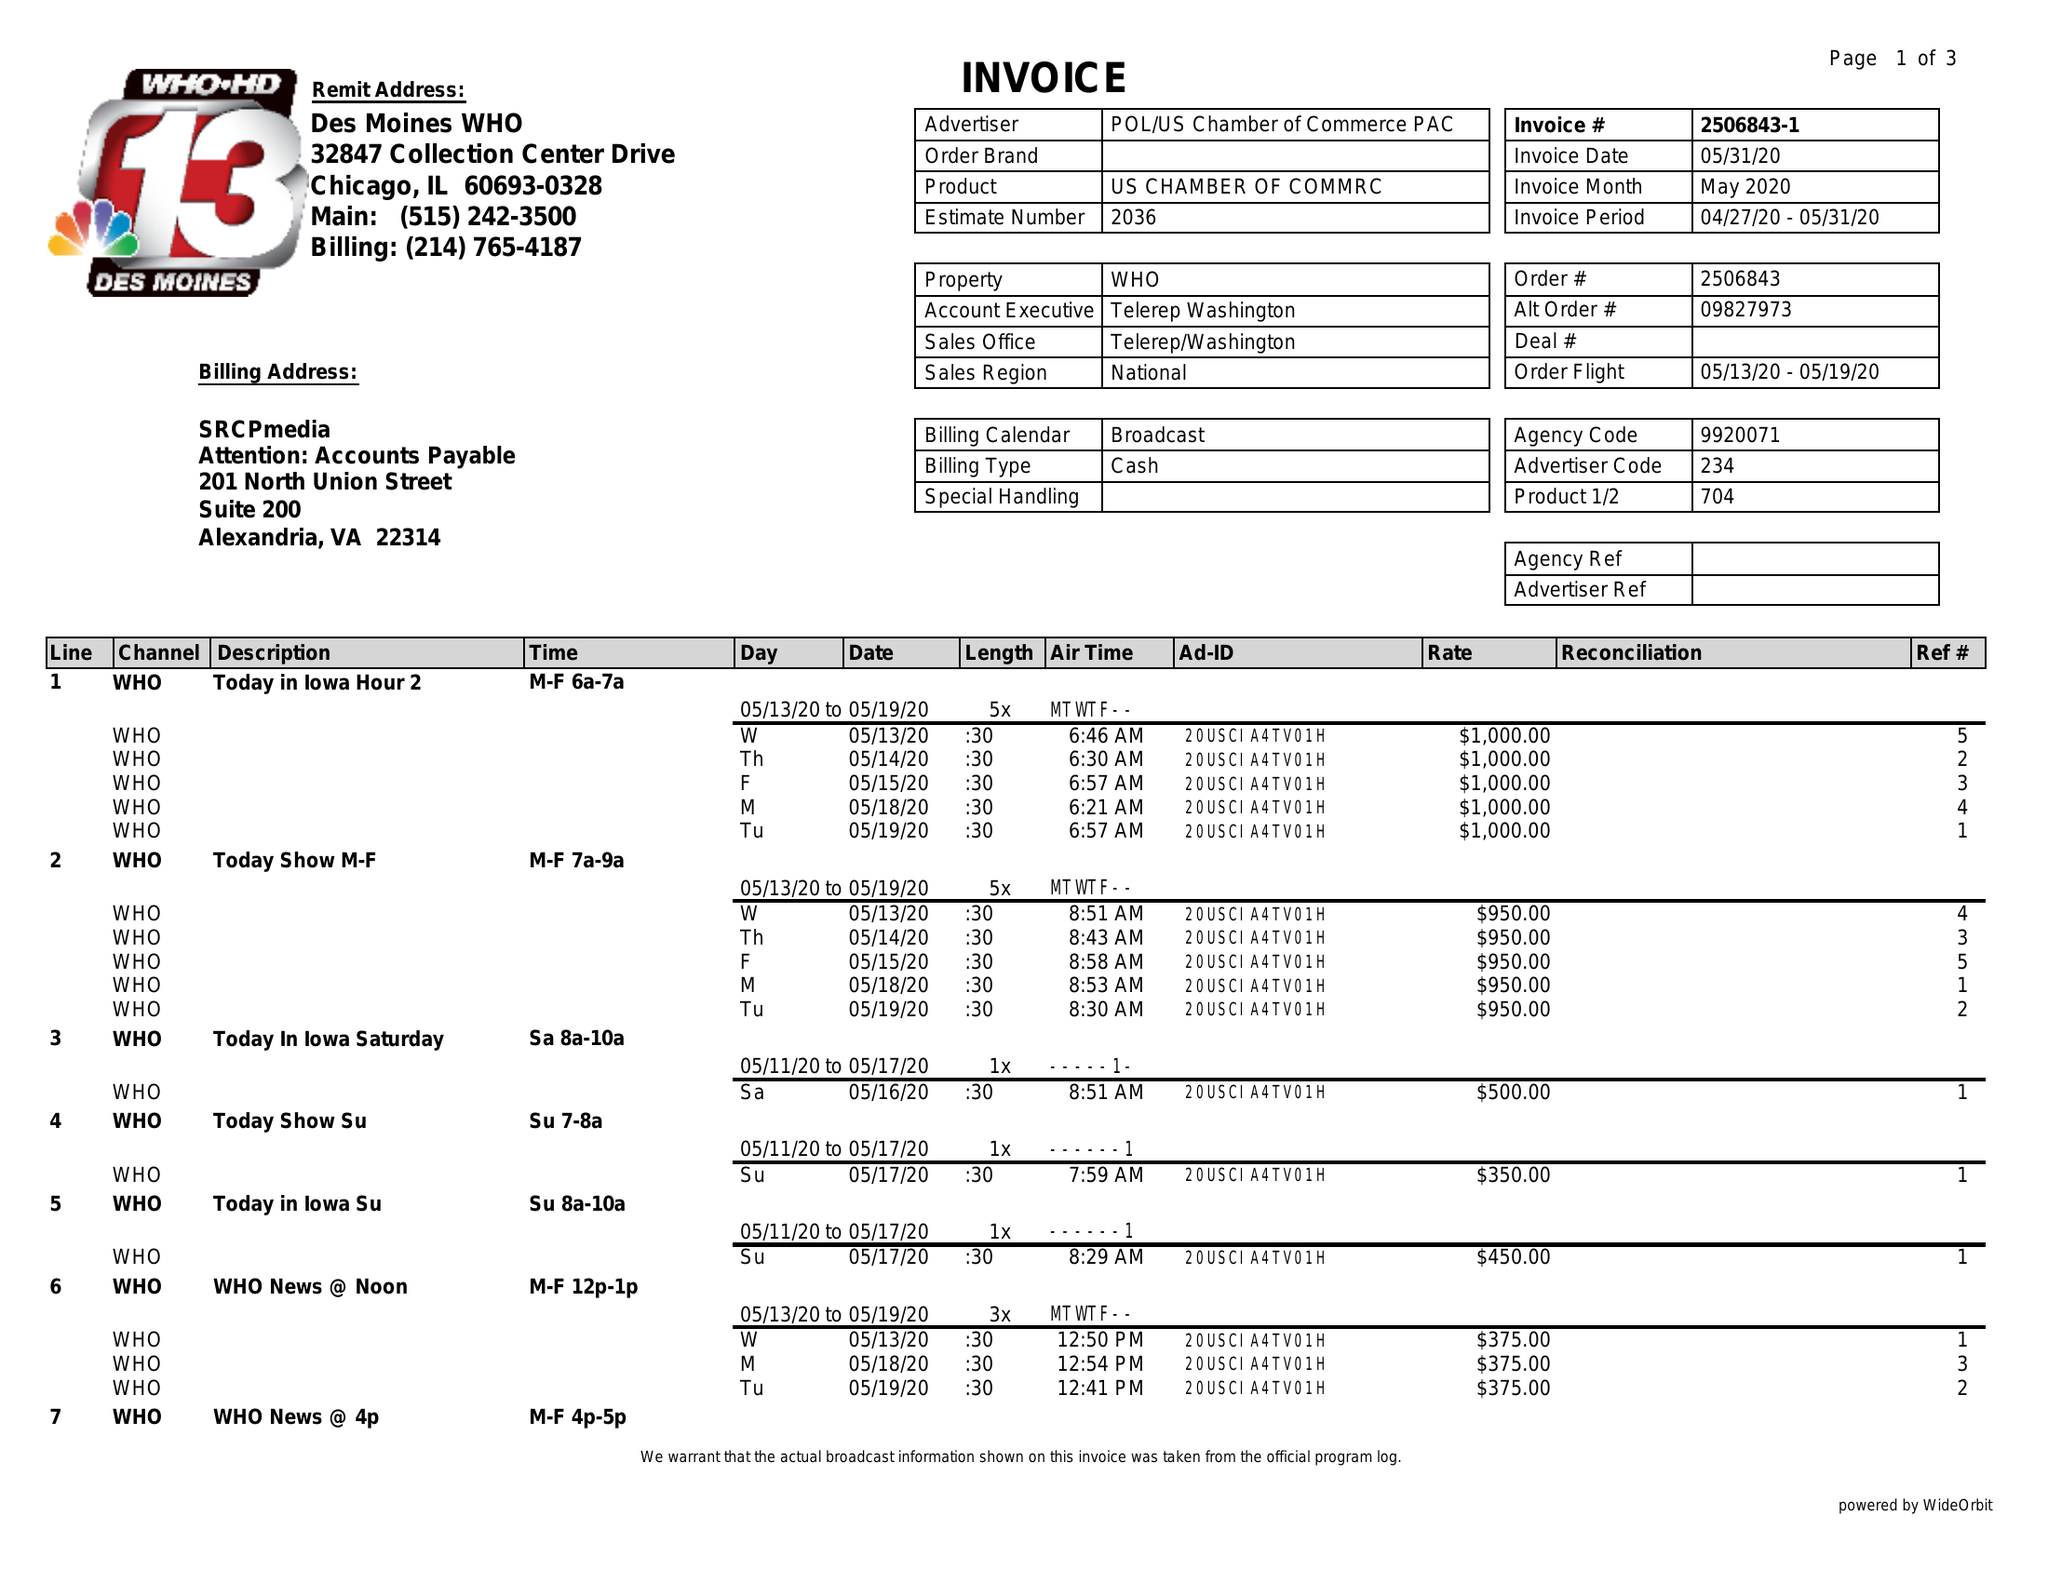What is the value for the contract_num?
Answer the question using a single word or phrase. 2506843 